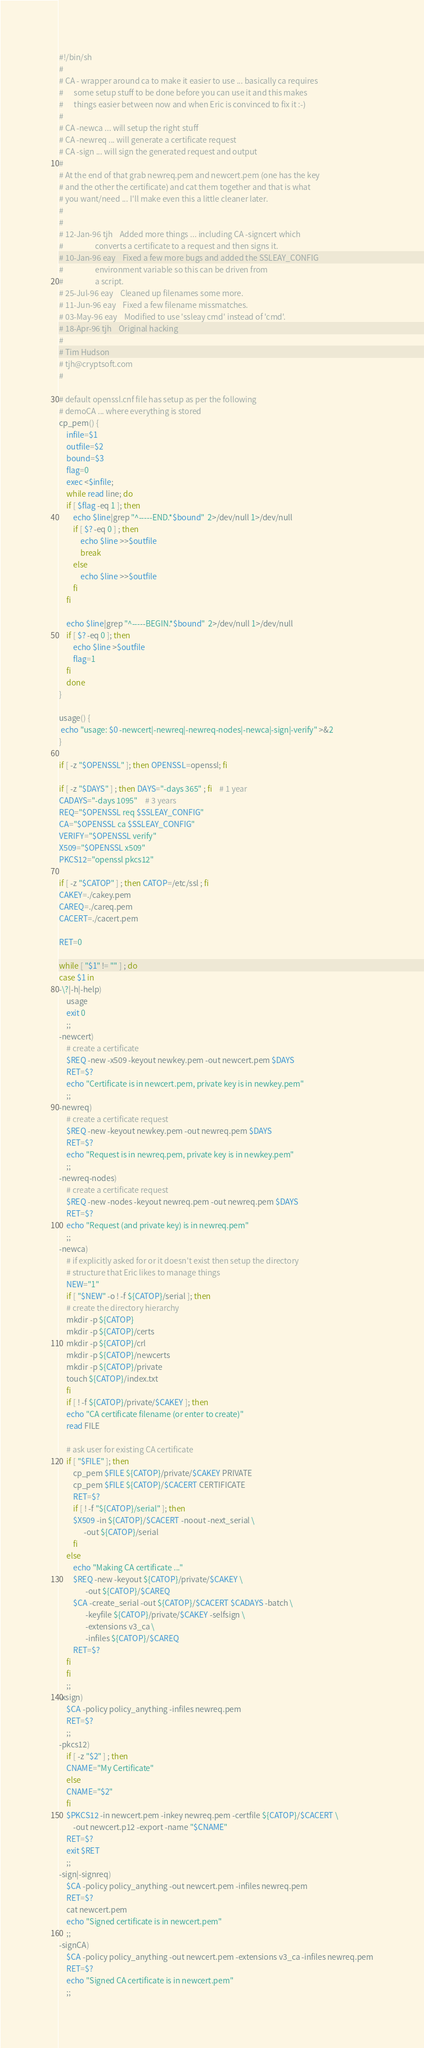Convert code to text. <code><loc_0><loc_0><loc_500><loc_500><_Bash_>#!/bin/sh
#
# CA - wrapper around ca to make it easier to use ... basically ca requires
#      some setup stuff to be done before you can use it and this makes
#      things easier between now and when Eric is convinced to fix it :-)
#
# CA -newca ... will setup the right stuff
# CA -newreq ... will generate a certificate request
# CA -sign ... will sign the generated request and output
#
# At the end of that grab newreq.pem and newcert.pem (one has the key
# and the other the certificate) and cat them together and that is what
# you want/need ... I'll make even this a little cleaner later.
#
#
# 12-Jan-96 tjh    Added more things ... including CA -signcert which
#                  converts a certificate to a request and then signs it.
# 10-Jan-96 eay    Fixed a few more bugs and added the SSLEAY_CONFIG
#                  environment variable so this can be driven from
#                  a script.
# 25-Jul-96 eay    Cleaned up filenames some more.
# 11-Jun-96 eay    Fixed a few filename missmatches.
# 03-May-96 eay    Modified to use 'ssleay cmd' instead of 'cmd'.
# 18-Apr-96 tjh    Original hacking
#
# Tim Hudson
# tjh@cryptsoft.com
#

# default openssl.cnf file has setup as per the following
# demoCA ... where everything is stored
cp_pem() {
    infile=$1
    outfile=$2
    bound=$3
    flag=0
    exec <$infile;
    while read line; do
	if [ $flag -eq 1 ]; then
		echo $line|grep "^-----END.*$bound"  2>/dev/null 1>/dev/null
		if [ $? -eq 0 ] ; then
			echo $line >>$outfile
			break
		else
			echo $line >>$outfile
		fi
	fi

	echo $line|grep "^-----BEGIN.*$bound"  2>/dev/null 1>/dev/null
	if [ $? -eq 0 ]; then
		echo $line >$outfile
		flag=1
	fi
    done
}

usage() {
 echo "usage: $0 -newcert|-newreq|-newreq-nodes|-newca|-sign|-verify" >&2
}

if [ -z "$OPENSSL" ]; then OPENSSL=openssl; fi

if [ -z "$DAYS" ] ; then DAYS="-days 365" ; fi	# 1 year
CADAYS="-days 1095"	# 3 years
REQ="$OPENSSL req $SSLEAY_CONFIG"
CA="$OPENSSL ca $SSLEAY_CONFIG"
VERIFY="$OPENSSL verify"
X509="$OPENSSL x509"
PKCS12="openssl pkcs12"

if [ -z "$CATOP" ] ; then CATOP=/etc/ssl ; fi
CAKEY=./cakey.pem
CAREQ=./careq.pem
CACERT=./cacert.pem

RET=0

while [ "$1" != "" ] ; do
case $1 in
-\?|-h|-help)
    usage
    exit 0
    ;;
-newcert)
    # create a certificate
    $REQ -new -x509 -keyout newkey.pem -out newcert.pem $DAYS
    RET=$?
    echo "Certificate is in newcert.pem, private key is in newkey.pem"
    ;;
-newreq)
    # create a certificate request
    $REQ -new -keyout newkey.pem -out newreq.pem $DAYS
    RET=$?
    echo "Request is in newreq.pem, private key is in newkey.pem"
    ;;
-newreq-nodes) 
    # create a certificate request
    $REQ -new -nodes -keyout newreq.pem -out newreq.pem $DAYS
    RET=$?
    echo "Request (and private key) is in newreq.pem"
    ;;
-newca)
    # if explicitly asked for or it doesn't exist then setup the directory
    # structure that Eric likes to manage things
    NEW="1"
    if [ "$NEW" -o ! -f ${CATOP}/serial ]; then
	# create the directory hierarchy
	mkdir -p ${CATOP}
	mkdir -p ${CATOP}/certs
	mkdir -p ${CATOP}/crl
	mkdir -p ${CATOP}/newcerts
	mkdir -p ${CATOP}/private
	touch ${CATOP}/index.txt
    fi
    if [ ! -f ${CATOP}/private/$CAKEY ]; then
	echo "CA certificate filename (or enter to create)"
	read FILE

	# ask user for existing CA certificate
	if [ "$FILE" ]; then
	    cp_pem $FILE ${CATOP}/private/$CAKEY PRIVATE
	    cp_pem $FILE ${CATOP}/$CACERT CERTIFICATE
	    RET=$?
	    if [ ! -f "${CATOP}/serial" ]; then
		$X509 -in ${CATOP}/$CACERT -noout -next_serial \
		      -out ${CATOP}/serial
	    fi
	else
	    echo "Making CA certificate ..."
	    $REQ -new -keyout ${CATOP}/private/$CAKEY \
			   -out ${CATOP}/$CAREQ
	    $CA -create_serial -out ${CATOP}/$CACERT $CADAYS -batch \
			   -keyfile ${CATOP}/private/$CAKEY -selfsign \
			   -extensions v3_ca \
			   -infiles ${CATOP}/$CAREQ
	    RET=$?
	fi
    fi
    ;;
-xsign)
    $CA -policy policy_anything -infiles newreq.pem
    RET=$?
    ;;
-pkcs12)
    if [ -z "$2" ] ; then
	CNAME="My Certificate"
    else
	CNAME="$2"
    fi
    $PKCS12 -in newcert.pem -inkey newreq.pem -certfile ${CATOP}/$CACERT \
	    -out newcert.p12 -export -name "$CNAME"
    RET=$?
    exit $RET
    ;;
-sign|-signreq)
    $CA -policy policy_anything -out newcert.pem -infiles newreq.pem
    RET=$?
    cat newcert.pem
    echo "Signed certificate is in newcert.pem"
    ;;
-signCA)
    $CA -policy policy_anything -out newcert.pem -extensions v3_ca -infiles newreq.pem
    RET=$?
    echo "Signed CA certificate is in newcert.pem"
    ;;</code> 